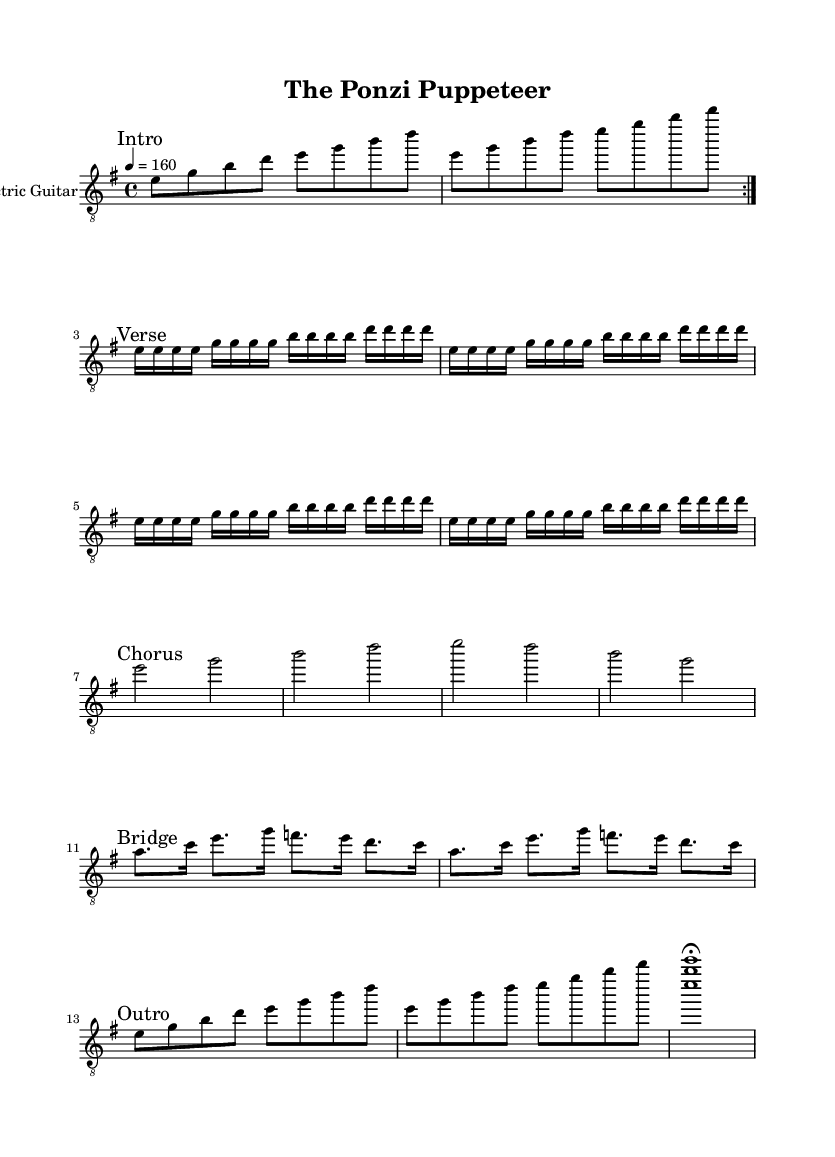What is the key signature of this music? The key signature is indicated at the beginning of the sheet music and shows that it is in E minor, which has one sharp (F#).
Answer: E minor What is the time signature of the piece? The time signature is shown on the left side, which indicates that the piece is in 4/4 time, meaning there are four beats in each measure.
Answer: 4/4 What is the tempo marking for the piece? The tempo is shown at the top of the sheet music and indicates that the piece should be played at a tempo of 160 beats per minute (BPM).
Answer: 160 How many measures are in the bridge section? The bridge section consists of two repeated lines of music, each containing four measures, totaling eight measures in this section.
Answer: 8 What instrument is this sheet music for? The sheet music clearly specifies that it is for the Electric Guitar as mentioned in the instrument name at the beginning of the staff.
Answer: Electric Guitar What is the rhythmic pattern present in the verse section? In the verse section, the rhythmic pattern consists of mainly sixteenth notes, creating a driving and fast-paced feel typical of Metal music.
Answer: Sixteenth notes How many times is the intro section repeated? The intro section is marked with "volta" notation which indicates that it should be repeated twice, making a total of two repetitions.
Answer: 2 